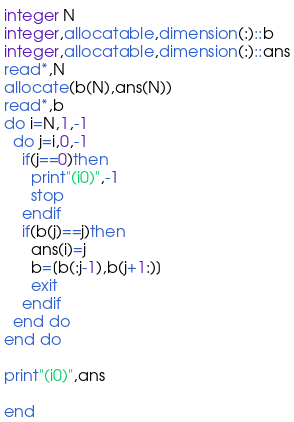Convert code to text. <code><loc_0><loc_0><loc_500><loc_500><_FORTRAN_>integer N
integer,allocatable,dimension(:)::b
integer,allocatable,dimension(:)::ans
read*,N
allocate(b(N),ans(N))
read*,b
do i=N,1,-1
  do j=i,0,-1
    if(j==0)then
      print"(i0)",-1
      stop
    endif
    if(b(j)==j)then
      ans(i)=j
      b=[b(:j-1),b(j+1:)]
      exit
    endif
  end do
end do

print"(i0)",ans

end</code> 